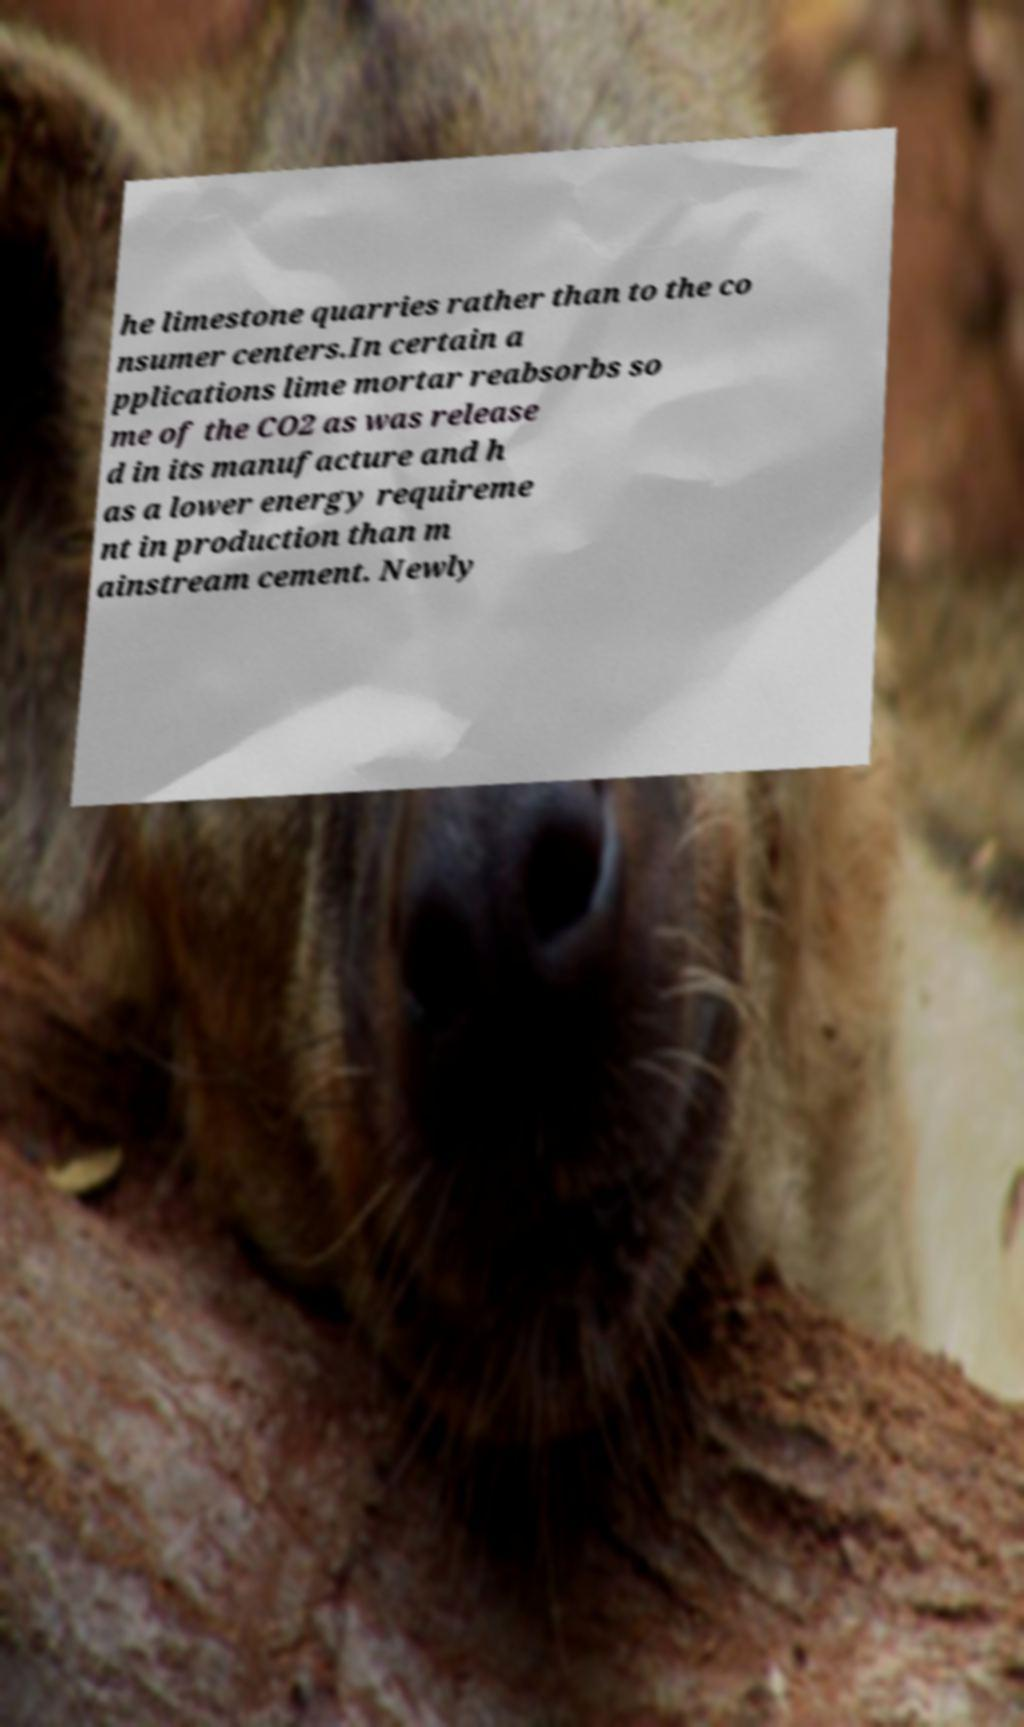Please identify and transcribe the text found in this image. he limestone quarries rather than to the co nsumer centers.In certain a pplications lime mortar reabsorbs so me of the CO2 as was release d in its manufacture and h as a lower energy requireme nt in production than m ainstream cement. Newly 